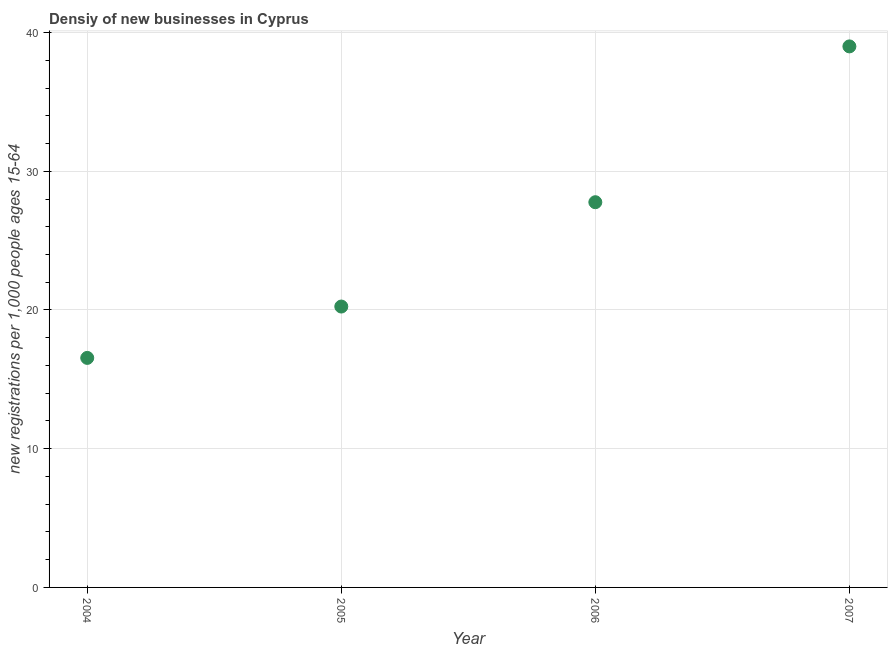What is the density of new business in 2005?
Keep it short and to the point. 20.25. Across all years, what is the maximum density of new business?
Provide a succinct answer. 39. Across all years, what is the minimum density of new business?
Your response must be concise. 16.55. In which year was the density of new business maximum?
Make the answer very short. 2007. What is the sum of the density of new business?
Offer a terse response. 103.56. What is the difference between the density of new business in 2004 and 2006?
Give a very brief answer. -11.22. What is the average density of new business per year?
Offer a terse response. 25.89. What is the median density of new business?
Keep it short and to the point. 24.01. In how many years, is the density of new business greater than 14 ?
Make the answer very short. 4. What is the ratio of the density of new business in 2004 to that in 2007?
Your answer should be compact. 0.42. What is the difference between the highest and the second highest density of new business?
Provide a short and direct response. 11.23. What is the difference between the highest and the lowest density of new business?
Your answer should be very brief. 22.45. Does the graph contain any zero values?
Give a very brief answer. No. Does the graph contain grids?
Your answer should be compact. Yes. What is the title of the graph?
Offer a terse response. Densiy of new businesses in Cyprus. What is the label or title of the X-axis?
Your response must be concise. Year. What is the label or title of the Y-axis?
Your answer should be compact. New registrations per 1,0 people ages 15-64. What is the new registrations per 1,000 people ages 15-64 in 2004?
Your answer should be compact. 16.55. What is the new registrations per 1,000 people ages 15-64 in 2005?
Provide a short and direct response. 20.25. What is the new registrations per 1,000 people ages 15-64 in 2006?
Your answer should be compact. 27.77. What is the new registrations per 1,000 people ages 15-64 in 2007?
Your answer should be compact. 39. What is the difference between the new registrations per 1,000 people ages 15-64 in 2004 and 2005?
Ensure brevity in your answer.  -3.7. What is the difference between the new registrations per 1,000 people ages 15-64 in 2004 and 2006?
Your response must be concise. -11.22. What is the difference between the new registrations per 1,000 people ages 15-64 in 2004 and 2007?
Your response must be concise. -22.45. What is the difference between the new registrations per 1,000 people ages 15-64 in 2005 and 2006?
Provide a short and direct response. -7.52. What is the difference between the new registrations per 1,000 people ages 15-64 in 2005 and 2007?
Offer a terse response. -18.75. What is the difference between the new registrations per 1,000 people ages 15-64 in 2006 and 2007?
Your answer should be very brief. -11.23. What is the ratio of the new registrations per 1,000 people ages 15-64 in 2004 to that in 2005?
Provide a succinct answer. 0.82. What is the ratio of the new registrations per 1,000 people ages 15-64 in 2004 to that in 2006?
Your answer should be compact. 0.6. What is the ratio of the new registrations per 1,000 people ages 15-64 in 2004 to that in 2007?
Offer a terse response. 0.42. What is the ratio of the new registrations per 1,000 people ages 15-64 in 2005 to that in 2006?
Provide a succinct answer. 0.73. What is the ratio of the new registrations per 1,000 people ages 15-64 in 2005 to that in 2007?
Keep it short and to the point. 0.52. What is the ratio of the new registrations per 1,000 people ages 15-64 in 2006 to that in 2007?
Ensure brevity in your answer.  0.71. 